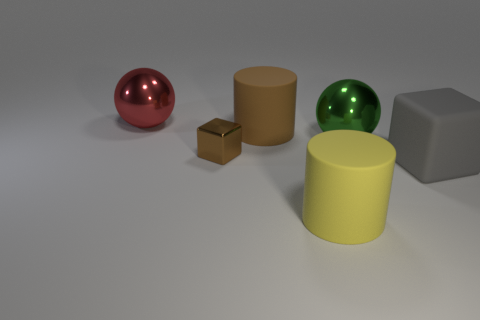What number of other objects are the same color as the small cube?
Your answer should be compact. 1. There is a matte cylinder that is behind the tiny metal block; is its color the same as the small cube?
Your response must be concise. Yes. There is another metallic thing that is the same shape as the big green shiny object; what is its size?
Offer a terse response. Large. What number of green things are the same size as the red ball?
Provide a succinct answer. 1. What is the brown cylinder made of?
Provide a short and direct response. Rubber. Are there any large objects on the left side of the large yellow rubber cylinder?
Offer a very short reply. Yes. There is a yellow object that is the same material as the large brown cylinder; what is its size?
Your answer should be very brief. Large. What number of cylinders are the same color as the tiny block?
Keep it short and to the point. 1. Are there fewer big yellow objects right of the yellow cylinder than large matte cubes that are in front of the large green metallic ball?
Provide a short and direct response. Yes. There is a rubber cylinder that is behind the large green object; what is its size?
Offer a terse response. Large. 